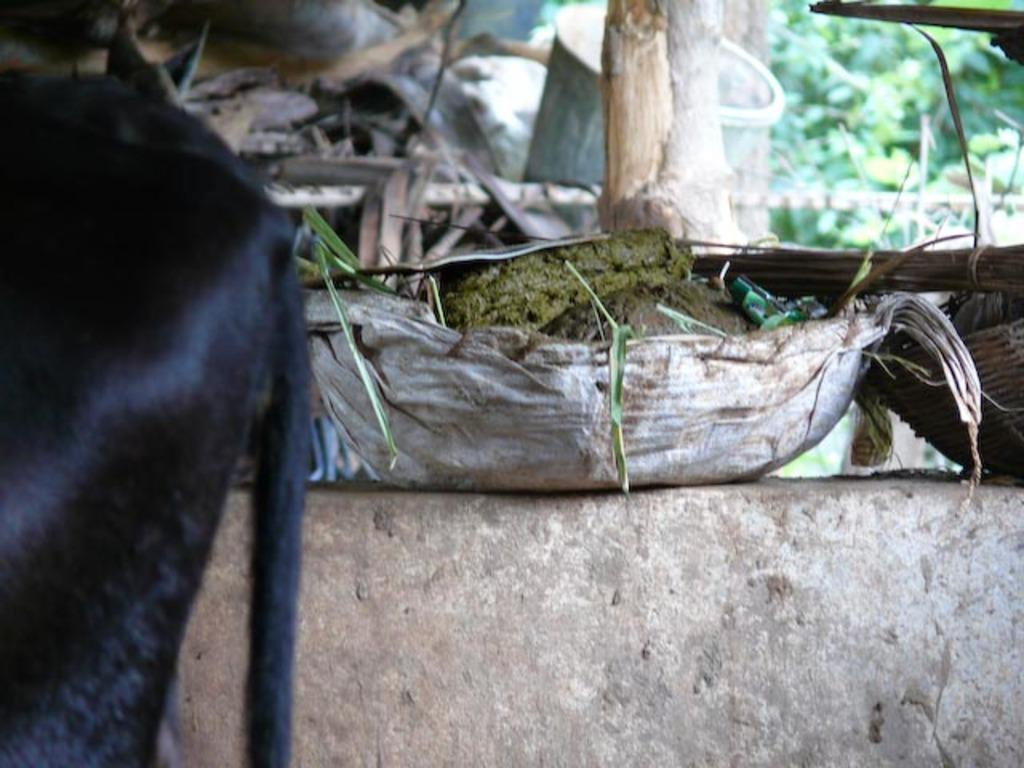What animal is located on the left side of the image? There is a cow on the left side of the image. What is the purpose of the basket with cow dung on the wall? The purpose of the basket with cow dung on the wall is not specified in the image. What type of vegetation can be seen in the background of the image? There are trees in the background of the image. What invention is being demonstrated by the cow in the image? There is no invention being demonstrated by the cow in the image; it is simply a cow standing on the left side. 